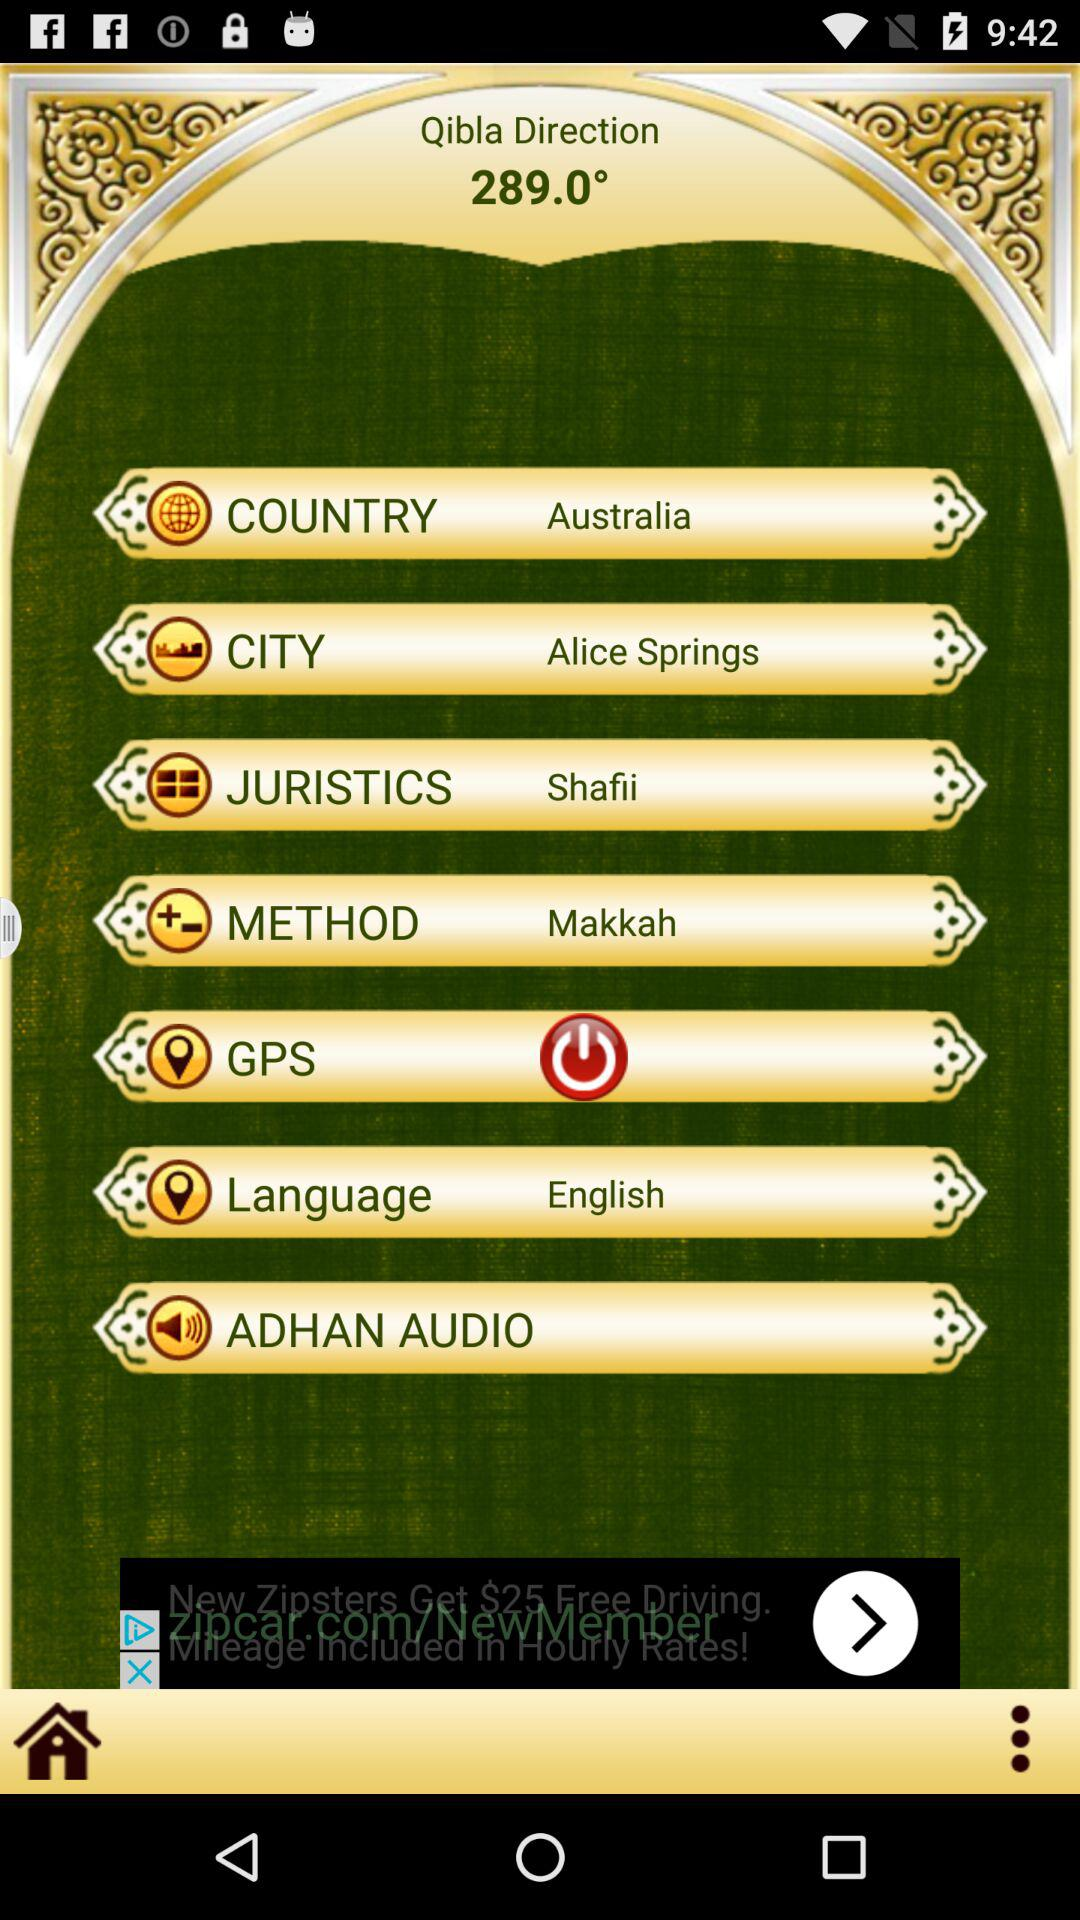What is the direction of Qibla? The direction is 289.0°. 